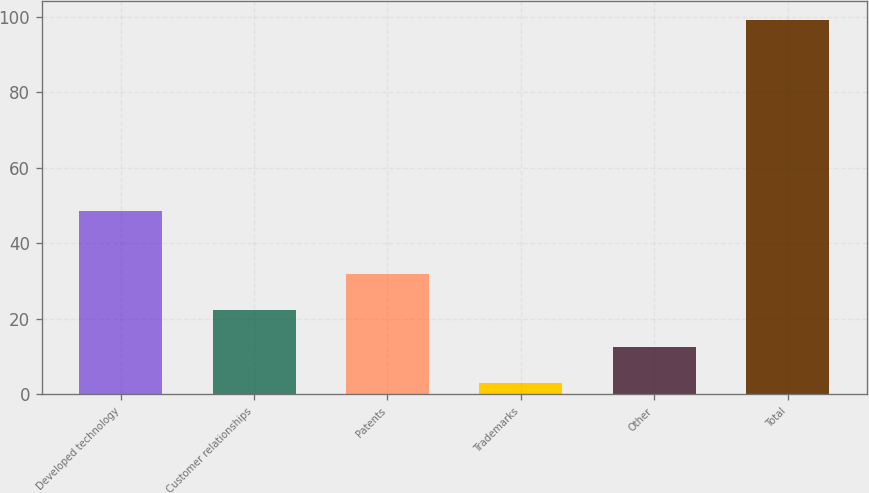Convert chart to OTSL. <chart><loc_0><loc_0><loc_500><loc_500><bar_chart><fcel>Developed technology<fcel>Customer relationships<fcel>Patents<fcel>Trademarks<fcel>Other<fcel>Total<nl><fcel>48.5<fcel>22.26<fcel>31.89<fcel>3<fcel>12.63<fcel>99.3<nl></chart> 